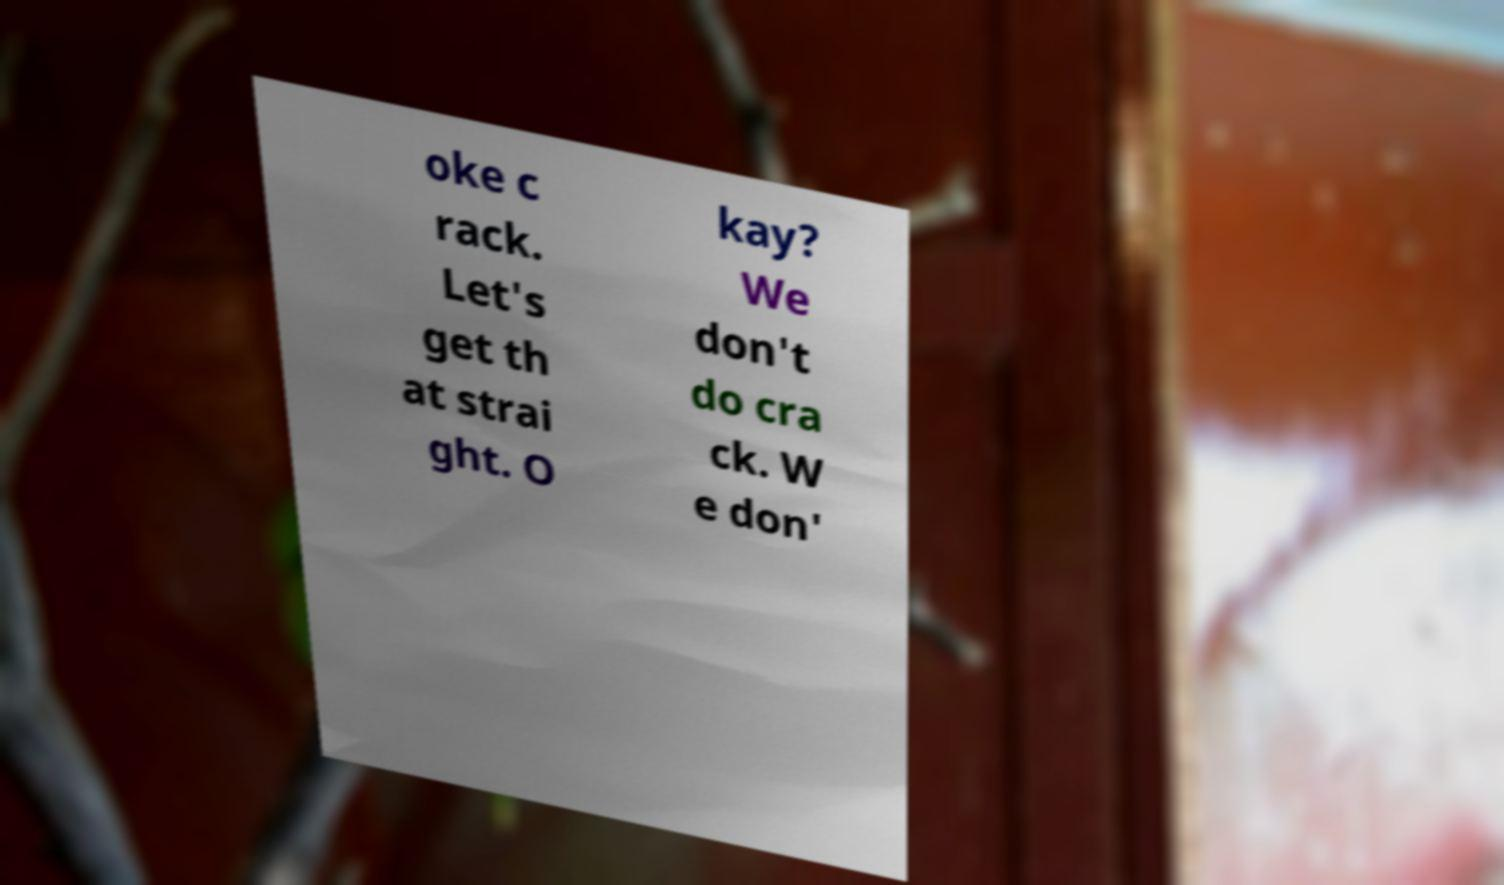Can you accurately transcribe the text from the provided image for me? oke c rack. Let's get th at strai ght. O kay? We don't do cra ck. W e don' 